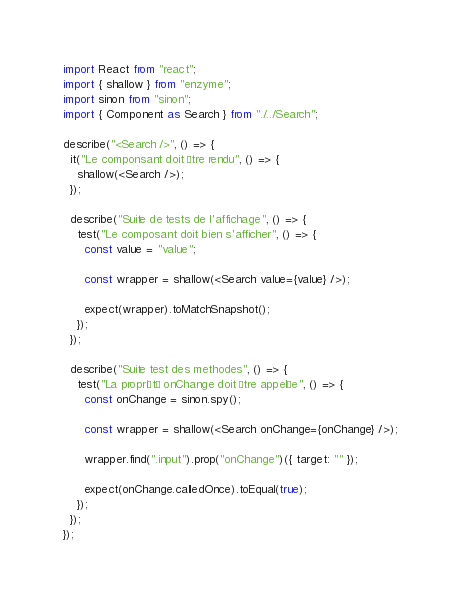<code> <loc_0><loc_0><loc_500><loc_500><_JavaScript_>import React from "react";
import { shallow } from "enzyme";
import sinon from "sinon";
import { Component as Search } from "./../Search";

describe("<Search />", () => {
  it("Le componsant doit être rendu", () => {
    shallow(<Search />);
  });

  describe("Suite de tests de l'affichage", () => {
    test("Le composant doit bien s'afficher", () => {
      const value = "value";

      const wrapper = shallow(<Search value={value} />);

      expect(wrapper).toMatchSnapshot();
    });
  });

  describe("Suite test des methodes", () => {
    test("La propriété onChange doit être appelée", () => {
      const onChange = sinon.spy();

      const wrapper = shallow(<Search onChange={onChange} />);

      wrapper.find(".input").prop("onChange")({ target: "" });

      expect(onChange.calledOnce).toEqual(true);
    });
  });
});
</code> 